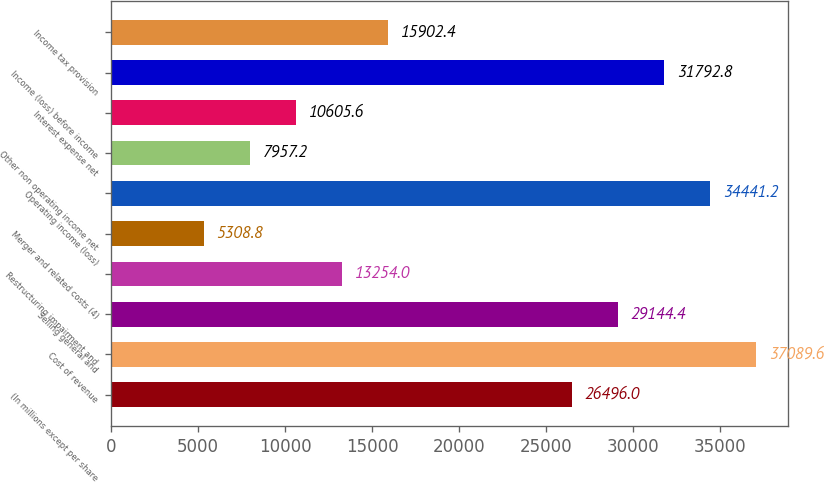Convert chart. <chart><loc_0><loc_0><loc_500><loc_500><bar_chart><fcel>(In millions except per share<fcel>Cost of revenue<fcel>Selling general and<fcel>Restructuring impairment and<fcel>Merger and related costs (4)<fcel>Operating income (loss)<fcel>Other non operating income net<fcel>Interest expense net<fcel>Income (loss) before income<fcel>Income tax provision<nl><fcel>26496<fcel>37089.6<fcel>29144.4<fcel>13254<fcel>5308.8<fcel>34441.2<fcel>7957.2<fcel>10605.6<fcel>31792.8<fcel>15902.4<nl></chart> 